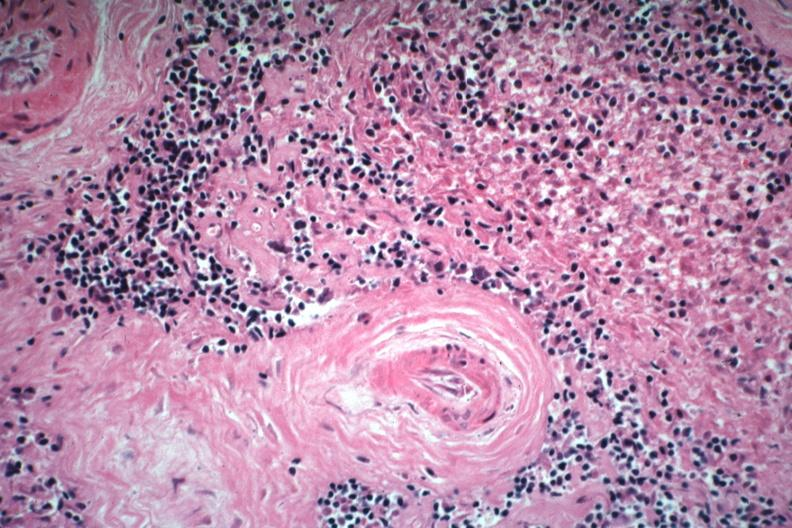what does this image show?
Answer the question using a single word or phrase. Two basophilic bodies and periarterial fibrosis excellent example of rarely seen lupus lesion 